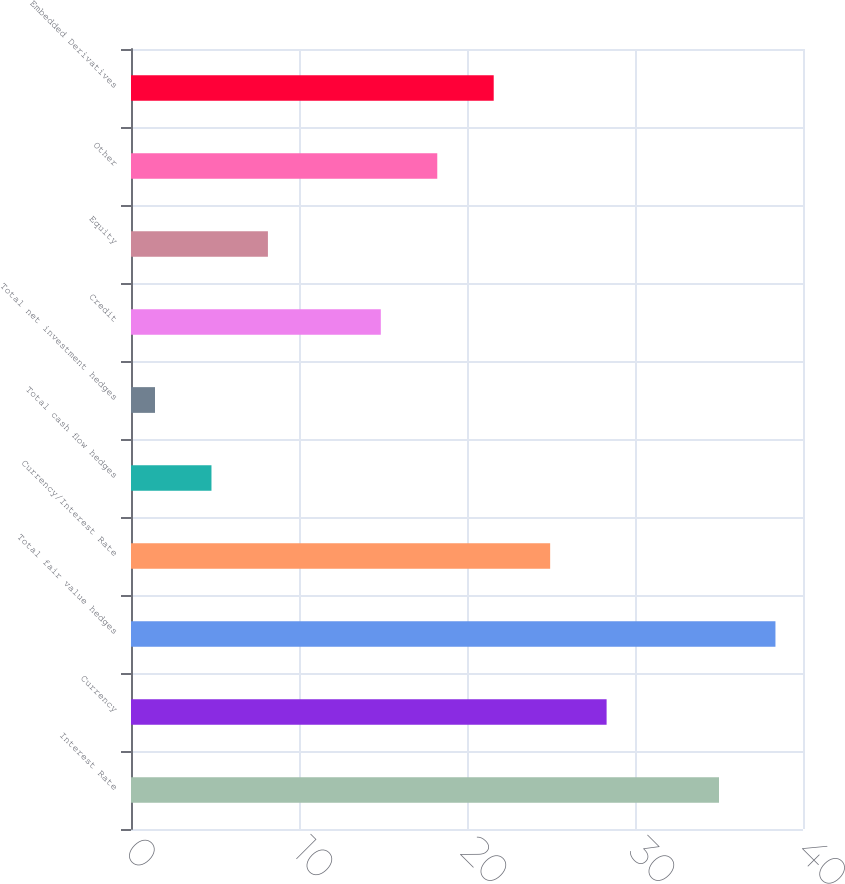Convert chart. <chart><loc_0><loc_0><loc_500><loc_500><bar_chart><fcel>Interest Rate<fcel>Currency<fcel>Total fair value hedges<fcel>Currency/Interest Rate<fcel>Total cash flow hedges<fcel>Total net investment hedges<fcel>Credit<fcel>Equity<fcel>Other<fcel>Embedded Derivatives<nl><fcel>35<fcel>28.31<fcel>38.36<fcel>24.95<fcel>4.79<fcel>1.43<fcel>14.87<fcel>8.15<fcel>18.23<fcel>21.59<nl></chart> 